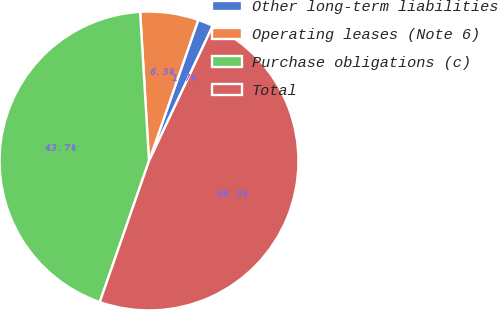<chart> <loc_0><loc_0><loc_500><loc_500><pie_chart><fcel>Other long-term liabilities<fcel>Operating leases (Note 6)<fcel>Purchase obligations (c)<fcel>Total<nl><fcel>1.67%<fcel>6.29%<fcel>43.71%<fcel>48.33%<nl></chart> 